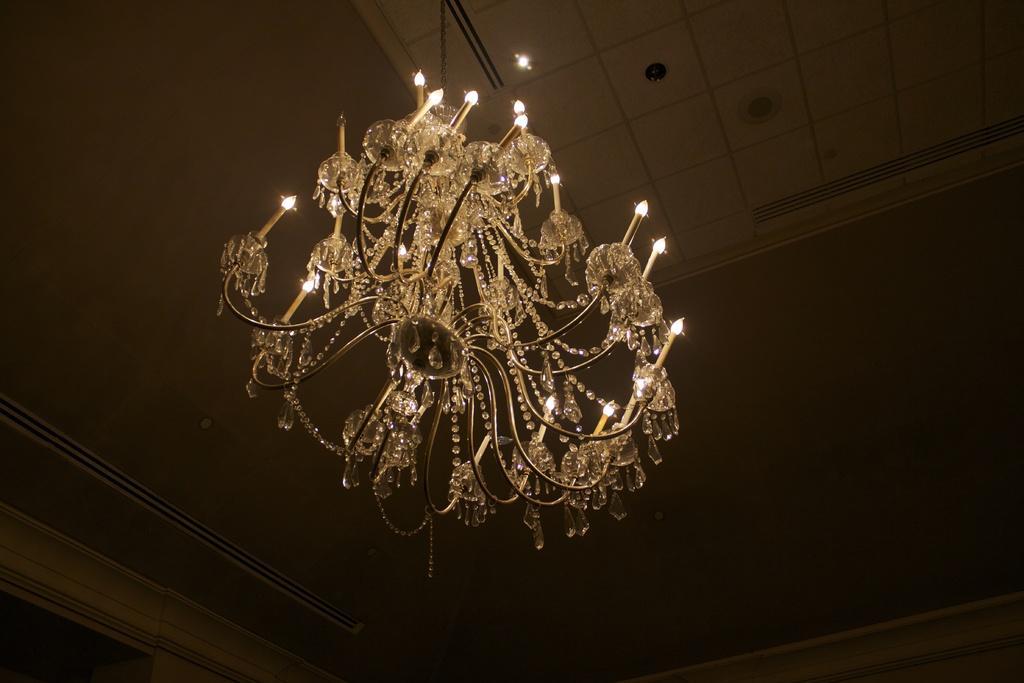How would you summarize this image in a sentence or two? In this image I can see a chandelier and the roof is in cream color. 